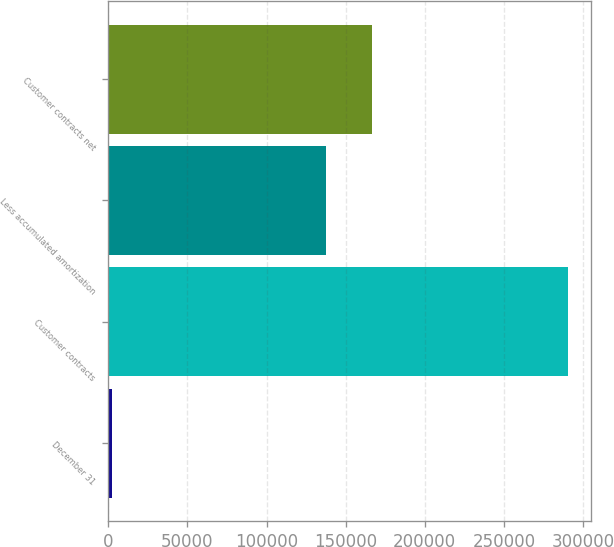<chart> <loc_0><loc_0><loc_500><loc_500><bar_chart><fcel>December 31<fcel>Customer contracts<fcel>Less accumulated amortization<fcel>Customer contracts net<nl><fcel>2017<fcel>290628<fcel>137759<fcel>166620<nl></chart> 